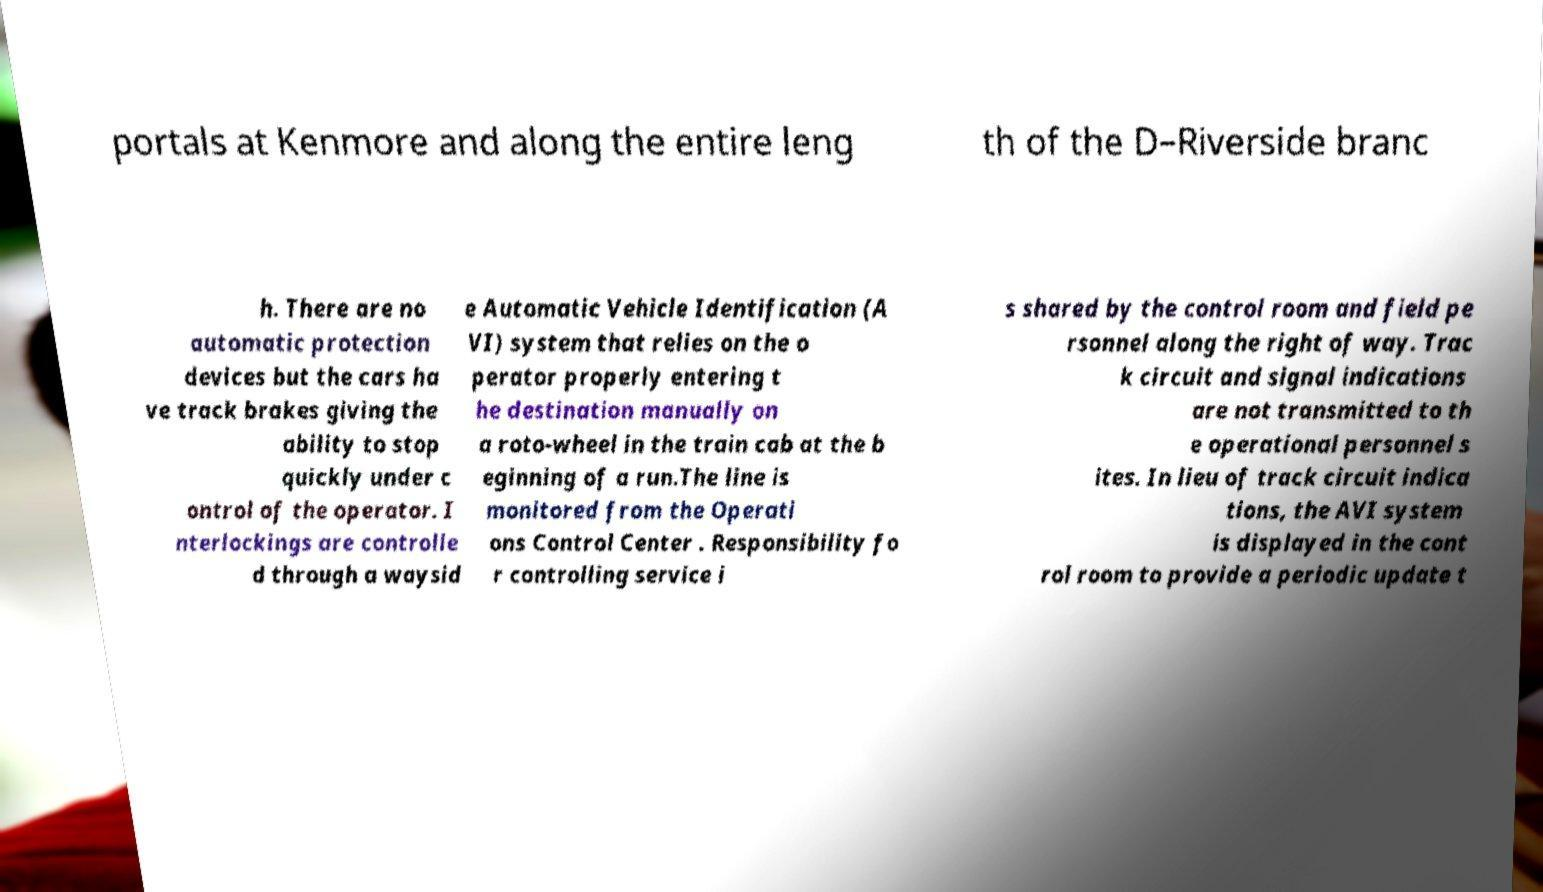Please identify and transcribe the text found in this image. portals at Kenmore and along the entire leng th of the D–Riverside branc h. There are no automatic protection devices but the cars ha ve track brakes giving the ability to stop quickly under c ontrol of the operator. I nterlockings are controlle d through a waysid e Automatic Vehicle Identification (A VI) system that relies on the o perator properly entering t he destination manually on a roto-wheel in the train cab at the b eginning of a run.The line is monitored from the Operati ons Control Center . Responsibility fo r controlling service i s shared by the control room and field pe rsonnel along the right of way. Trac k circuit and signal indications are not transmitted to th e operational personnel s ites. In lieu of track circuit indica tions, the AVI system is displayed in the cont rol room to provide a periodic update t 